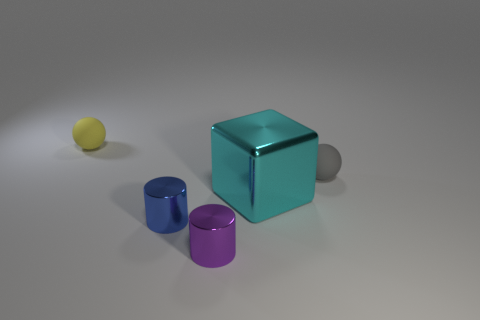Add 5 small metallic things. How many objects exist? 10 Subtract all blocks. How many objects are left? 4 Subtract 2 balls. How many balls are left? 0 Subtract all purple balls. How many purple blocks are left? 0 Subtract all purple metal things. Subtract all tiny yellow rubber things. How many objects are left? 3 Add 2 large cyan shiny objects. How many large cyan shiny objects are left? 3 Add 3 matte spheres. How many matte spheres exist? 5 Subtract 0 blue spheres. How many objects are left? 5 Subtract all gray blocks. Subtract all brown spheres. How many blocks are left? 1 